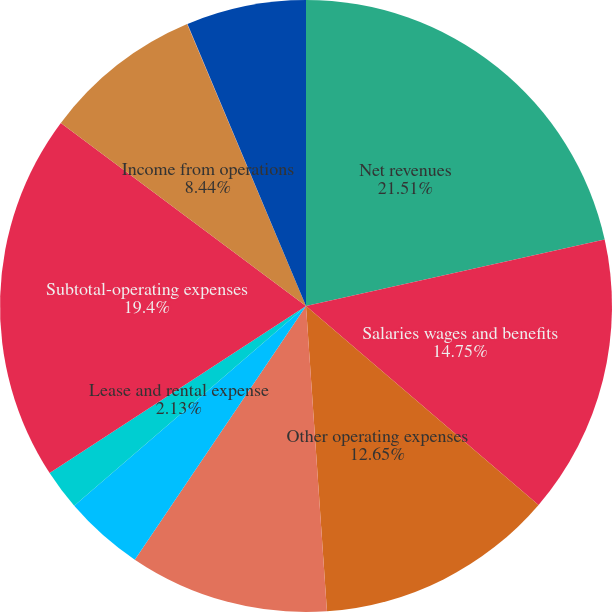<chart> <loc_0><loc_0><loc_500><loc_500><pie_chart><fcel>Net revenues<fcel>Salaries wages and benefits<fcel>Other operating expenses<fcel>Supplies expense<fcel>Depreciation and amortization<fcel>Lease and rental expense<fcel>Subtotal-operating expenses<fcel>Income from operations<fcel>Interest expense net<fcel>Income before income taxes<nl><fcel>21.51%<fcel>14.75%<fcel>12.65%<fcel>10.54%<fcel>4.23%<fcel>2.13%<fcel>19.4%<fcel>8.44%<fcel>0.02%<fcel>6.33%<nl></chart> 